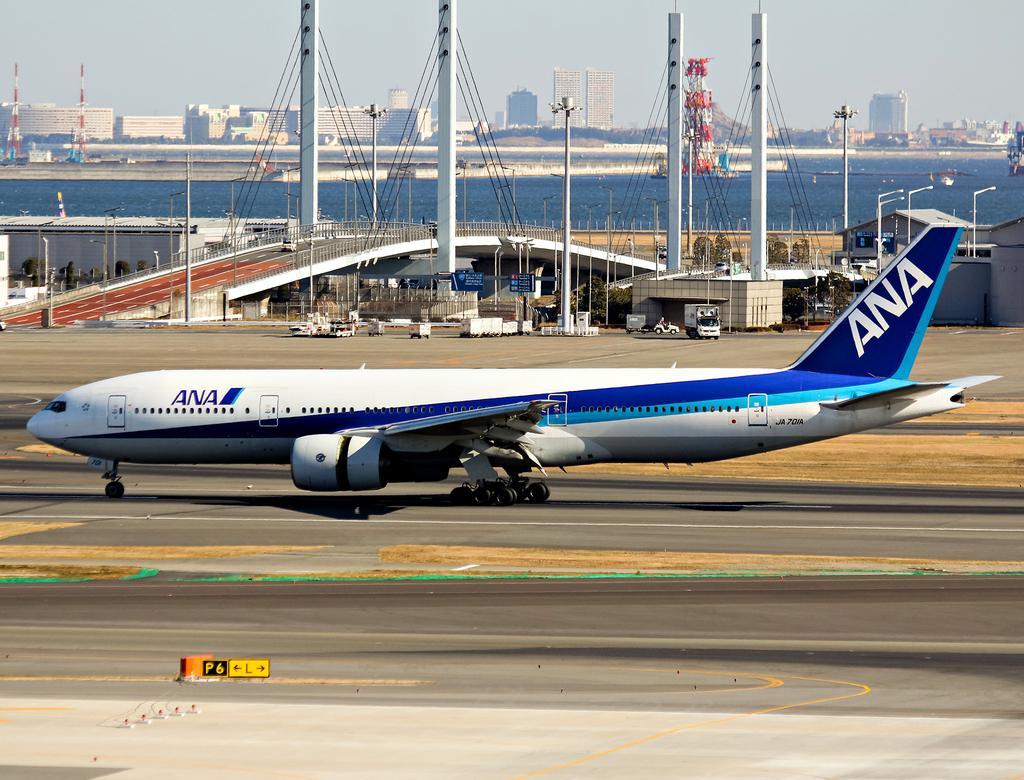Please provide a concise description of this image. In this image we can see an airplane on a runway. We can also see a bridge with some pillars and wires, some poles, a fence, a wall, a group of plants, a board, a house with roof and some vehicles on the ground. On the backside we can see a ship in a large water body, a group of buildings, trees, poles and the sky which looks cloudy. 